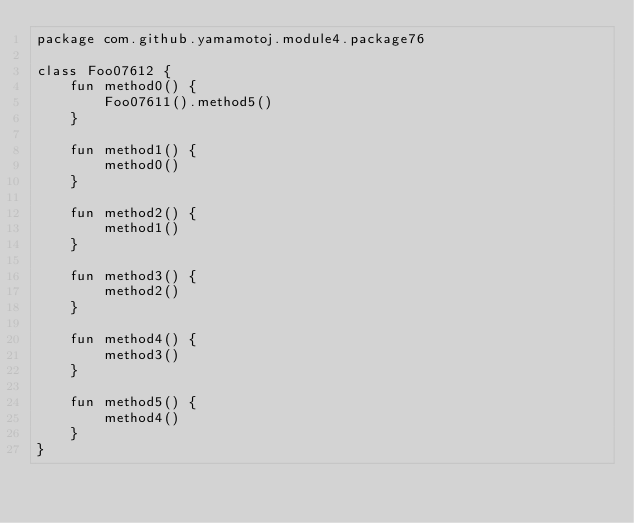<code> <loc_0><loc_0><loc_500><loc_500><_Kotlin_>package com.github.yamamotoj.module4.package76

class Foo07612 {
    fun method0() {
        Foo07611().method5()
    }

    fun method1() {
        method0()
    }

    fun method2() {
        method1()
    }

    fun method3() {
        method2()
    }

    fun method4() {
        method3()
    }

    fun method5() {
        method4()
    }
}
</code> 